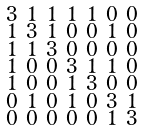<formula> <loc_0><loc_0><loc_500><loc_500>\begin{smallmatrix} 3 & 1 & 1 & 1 & 1 & 0 & 0 \\ 1 & 3 & 1 & 0 & 0 & 1 & 0 \\ 1 & 1 & 3 & 0 & 0 & 0 & 0 \\ 1 & 0 & 0 & 3 & 1 & 1 & 0 \\ 1 & 0 & 0 & 1 & 3 & 0 & 0 \\ 0 & 1 & 0 & 1 & 0 & 3 & 1 \\ 0 & 0 & 0 & 0 & 0 & 1 & 3 \end{smallmatrix}</formula> 